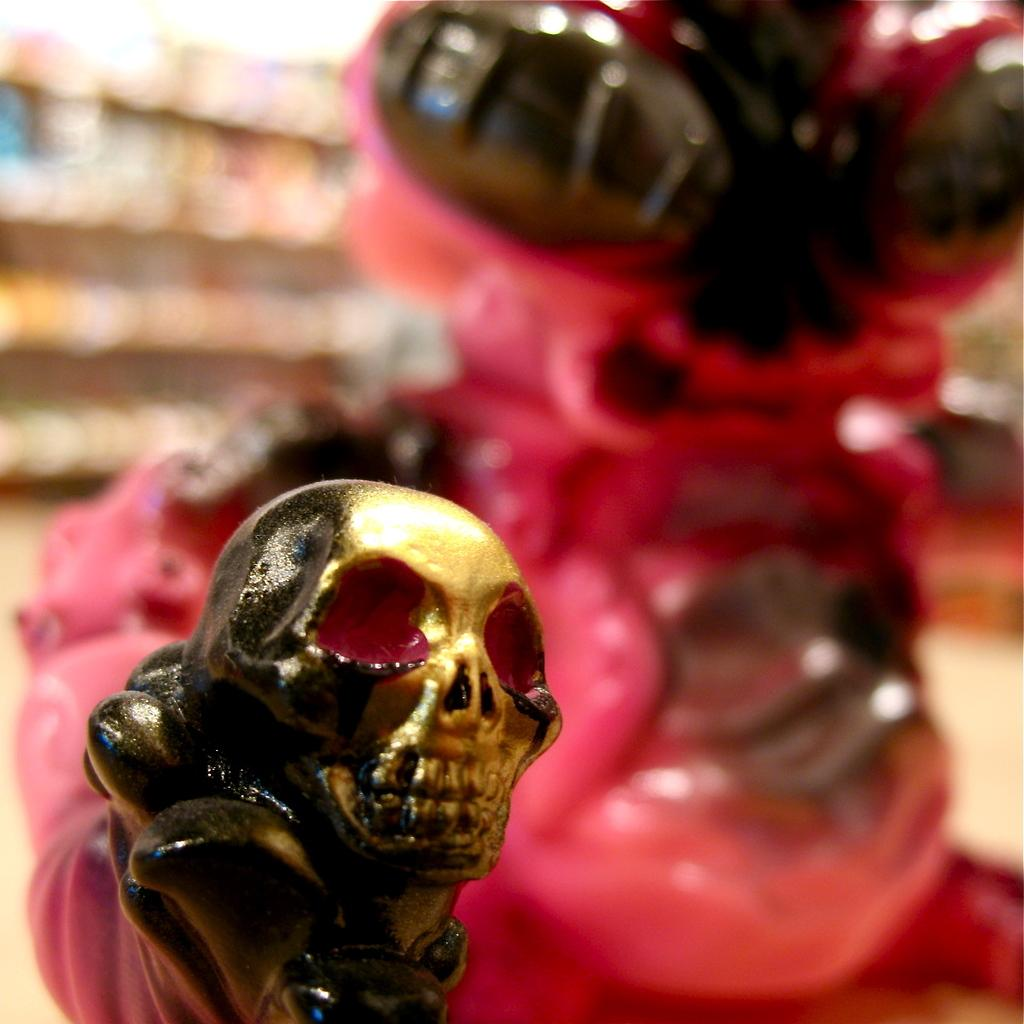What objects are in the foreground of the image? There are toys in the front of the image. How would you describe the background of the image? The background of the image is blurred. Where is the fan located in the image? There is no fan present in the image. What type of food is being served in the lunchroom in the image? There is no lunchroom present in the image. 